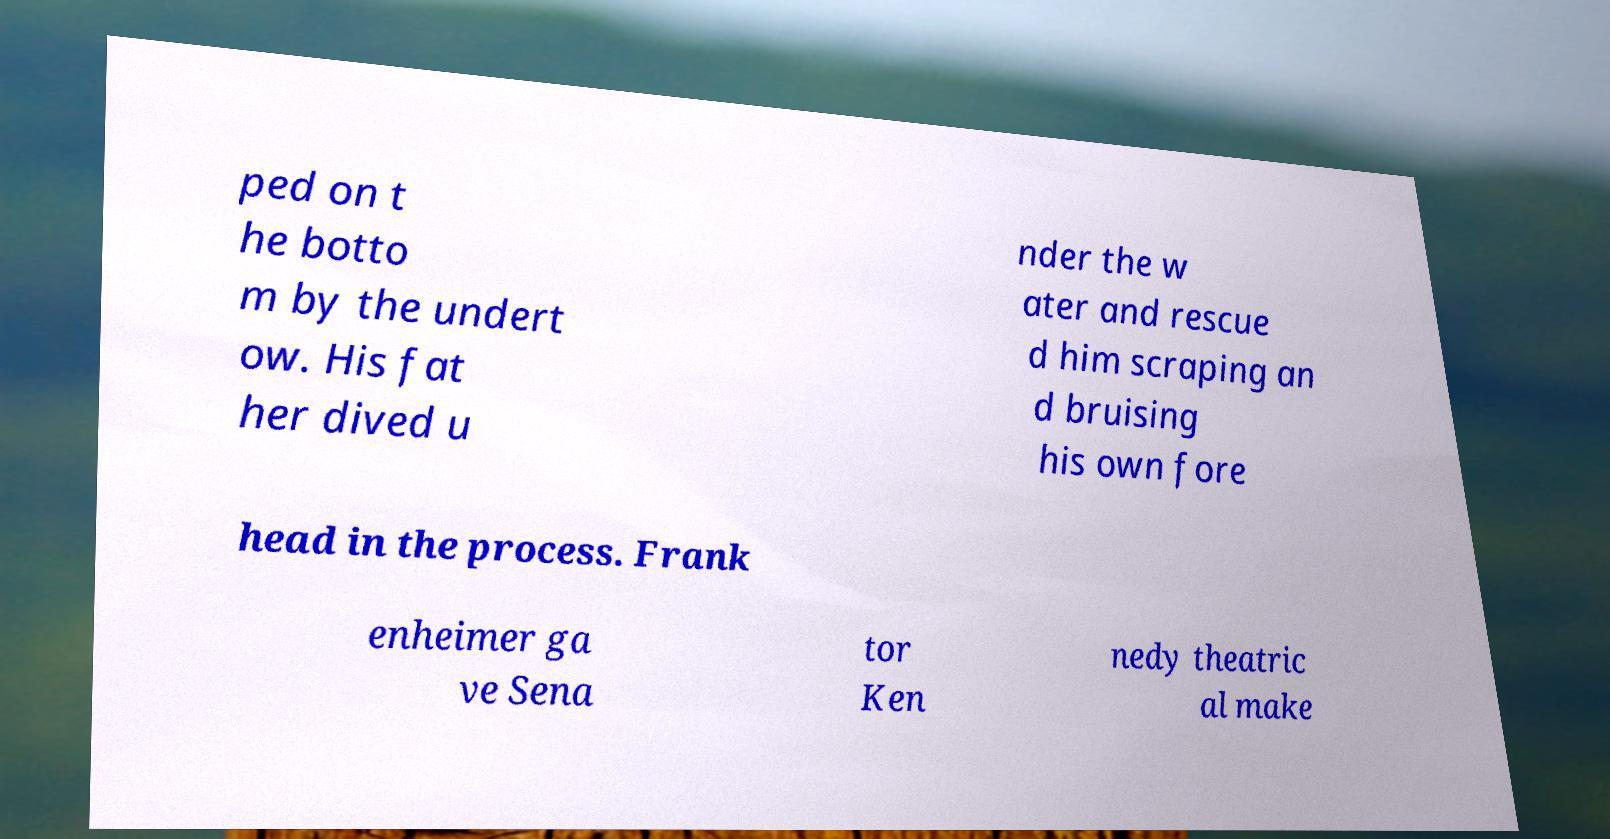Please read and relay the text visible in this image. What does it say? ped on t he botto m by the undert ow. His fat her dived u nder the w ater and rescue d him scraping an d bruising his own fore head in the process. Frank enheimer ga ve Sena tor Ken nedy theatric al make 